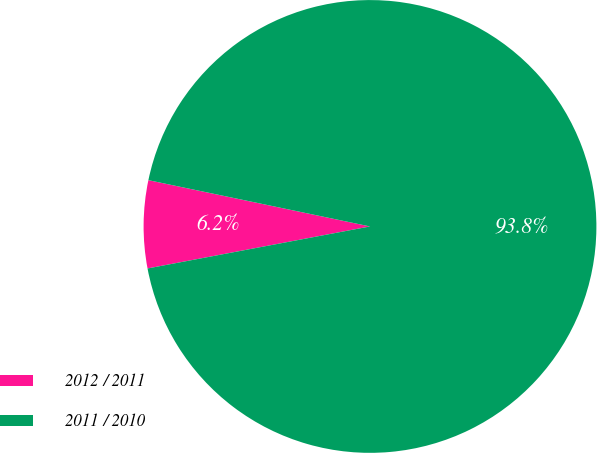Convert chart. <chart><loc_0><loc_0><loc_500><loc_500><pie_chart><fcel>2012 / 2011<fcel>2011 / 2010<nl><fcel>6.25%<fcel>93.75%<nl></chart> 